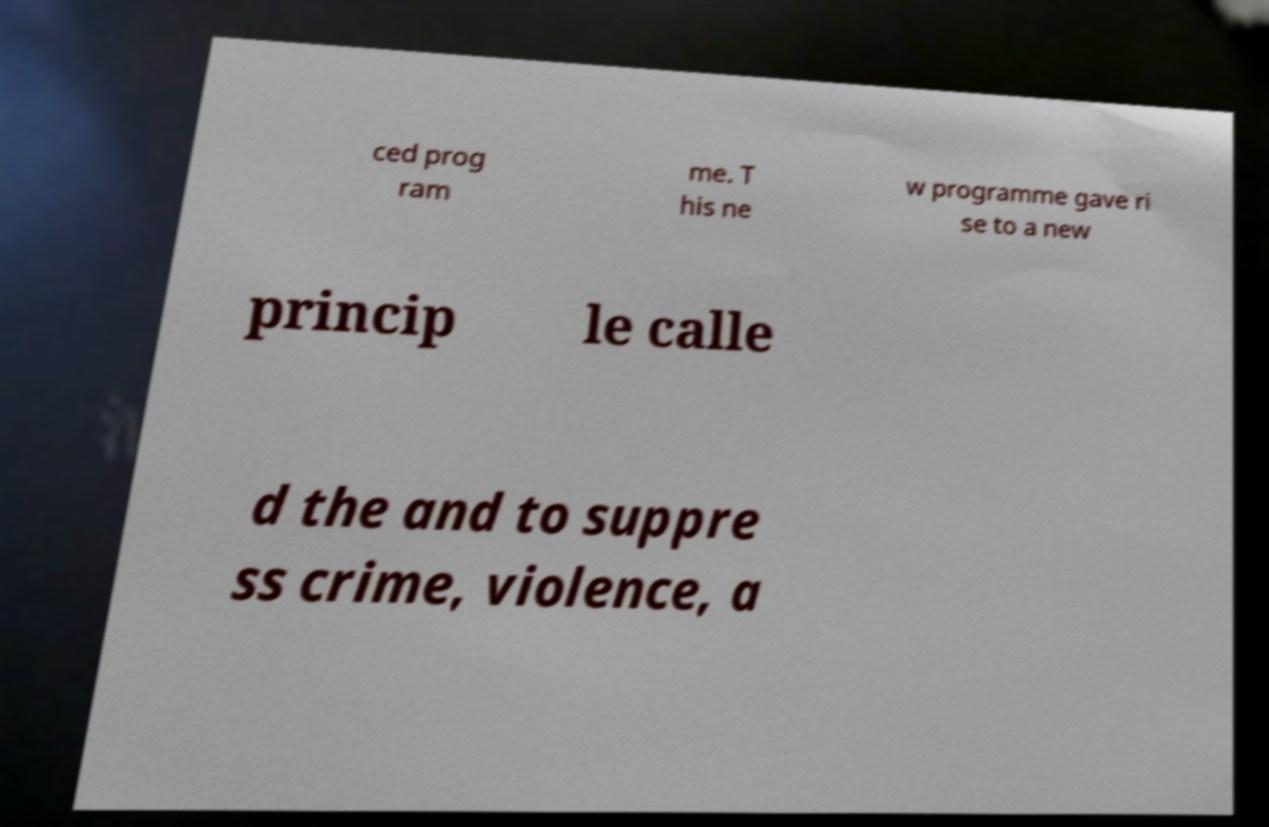I need the written content from this picture converted into text. Can you do that? ced prog ram me. T his ne w programme gave ri se to a new princip le calle d the and to suppre ss crime, violence, a 